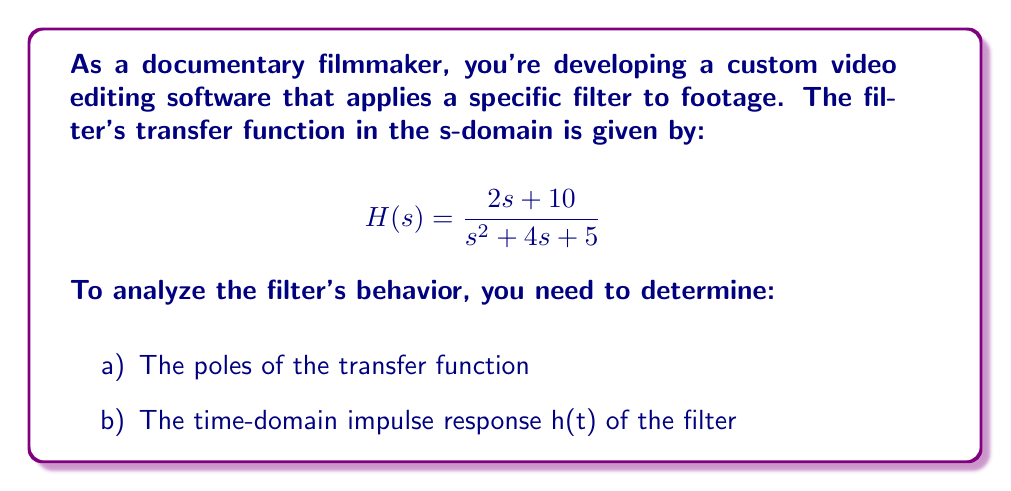Solve this math problem. Let's approach this problem step by step:

a) To find the poles of the transfer function, we need to find the roots of the denominator polynomial:

$$s^2 + 4s + 5 = 0$$

Using the quadratic formula: $s = \frac{-b \pm \sqrt{b^2 - 4ac}}{2a}$

Here, $a=1$, $b=4$, and $c=5$

$$s = \frac{-4 \pm \sqrt{4^2 - 4(1)(5)}}{2(1)} = \frac{-4 \pm \sqrt{16 - 20}}{2} = \frac{-4 \pm \sqrt{-4}}{2}$$

$$s = -2 \pm j$$

b) To find the time-domain impulse response h(t), we need to take the inverse Laplace transform of H(s):

First, let's perform partial fraction decomposition:

$$H(s) = \frac{2s + 10}{(s+2-j)(s+2+j)} = \frac{A}{s+2-j} + \frac{B}{s+2+j}$$

Solving for A and B:

$$A = \frac{2(2-j) + 10}{2j} = 1-j$$
$$B = \frac{2(2+j) + 10}{-2j} = 1+j$$

Now we can rewrite H(s) as:

$$H(s) = \frac{1-j}{s+2-j} + \frac{1+j}{s+2+j}$$

Taking the inverse Laplace transform:

$$h(t) = \mathcal{L}^{-1}\{H(s)\} = (1-j)e^{-(2-j)t} + (1+j)e^{-(2+j)t}$$

Simplifying:

$$h(t) = e^{-2t}[(1-j)e^{jt} + (1+j)e^{-jt}]$$
$$h(t) = e^{-2t}[(\cos t + j\sin t)(1-j) + (\cos t - j\sin t)(1+j)]$$
$$h(t) = e^{-2t}[2\cos t + 2\sin t]$$

Therefore, the time-domain impulse response is:

$$h(t) = 2e^{-2t}(\cos t + \sin t)$$
Answer: a) Poles: $s = -2 \pm j$
b) Impulse response: $h(t) = 2e^{-2t}(\cos t + \sin t)$ 